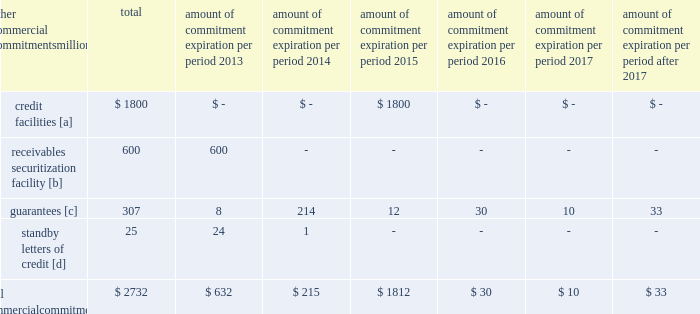Amount of commitment expiration per period other commercial commitments after millions total 2013 2014 2015 2016 2017 2017 .
[a] none of the credit facility was used as of december 31 , 2012 .
[b] $ 100 million of the receivables securitization facility was utilized at december 31 , 2012 , which is accounted for as debt .
The full program matures in july 2013 .
[c] includes guaranteed obligations related to our headquarters building , equipment financings , and affiliated operations .
[d] none of the letters of credit were drawn upon as of december 31 , 2012 .
Off-balance sheet arrangements guarantees 2013 at december 31 , 2012 , we were contingently liable for $ 307 million in guarantees .
We have recorded a liability of $ 2 million for the fair value of these obligations as of december 31 , 2012 and 2011 .
We entered into these contingent guarantees in the normal course of business , and they include guaranteed obligations related to our headquarters building , equipment financings , and affiliated operations .
The final guarantee expires in 2022 .
We are not aware of any existing event of default that would require us to satisfy these guarantees .
We do not expect that these guarantees will have a material adverse effect on our consolidated financial condition , results of operations , or liquidity .
Other matters labor agreements 2013 approximately 86% ( 86 % ) of our 45928 full-time-equivalent employees are represented by 14 major rail unions .
During the year , we concluded the most recent round of negotiations , which began in 2010 , with the ratification of new agreements by several unions that continued negotiating into 2012 .
All of the unions executed similar multi-year agreements that provide for higher employee cost sharing of employee health and welfare benefits and higher wages .
The current agreements will remain in effect until renegotiated under provisions of the railway labor act .
The next round of negotiations will begin in early 2015 .
Inflation 2013 long periods of inflation significantly increase asset replacement costs for capital-intensive companies .
As a result , assuming that we replace all operating assets at current price levels , depreciation charges ( on an inflation-adjusted basis ) would be substantially greater than historically reported amounts .
Derivative financial instruments 2013 we may use derivative financial instruments in limited instances to assist in managing our overall exposure to fluctuations in interest rates and fuel prices .
We are not a party to leveraged derivatives and , by policy , do not use derivative financial instruments for speculative purposes .
Derivative financial instruments qualifying for hedge accounting must maintain a specified level of effectiveness between the hedging instrument and the item being hedged , both at inception and throughout the hedged period .
We formally document the nature and relationships between the hedging instruments and hedged items at inception , as well as our risk-management objectives , strategies for undertaking the various hedge transactions , and method of assessing hedge effectiveness .
Changes in the fair market value of derivative financial instruments that do not qualify for hedge accounting are charged to earnings .
We may use swaps , collars , futures , and/or forward contracts to mitigate the risk of adverse movements in interest rates and fuel prices ; however , the use of these derivative financial instruments may limit future benefits from favorable price movements .
Market and credit risk 2013 we address market risk related to derivative financial instruments by selecting instruments with value fluctuations that highly correlate with the underlying hedged item .
We manage credit risk related to derivative financial instruments , which is minimal , by requiring high credit standards for counterparties and periodic settlements .
At december 31 , 2012 and 2011 , we were not required to provide collateral , nor had we received collateral , relating to our hedging activities. .
What percentage of total commercial commitments are credit facilities? 
Computations: (1800 / 2732)
Answer: 0.65886. 